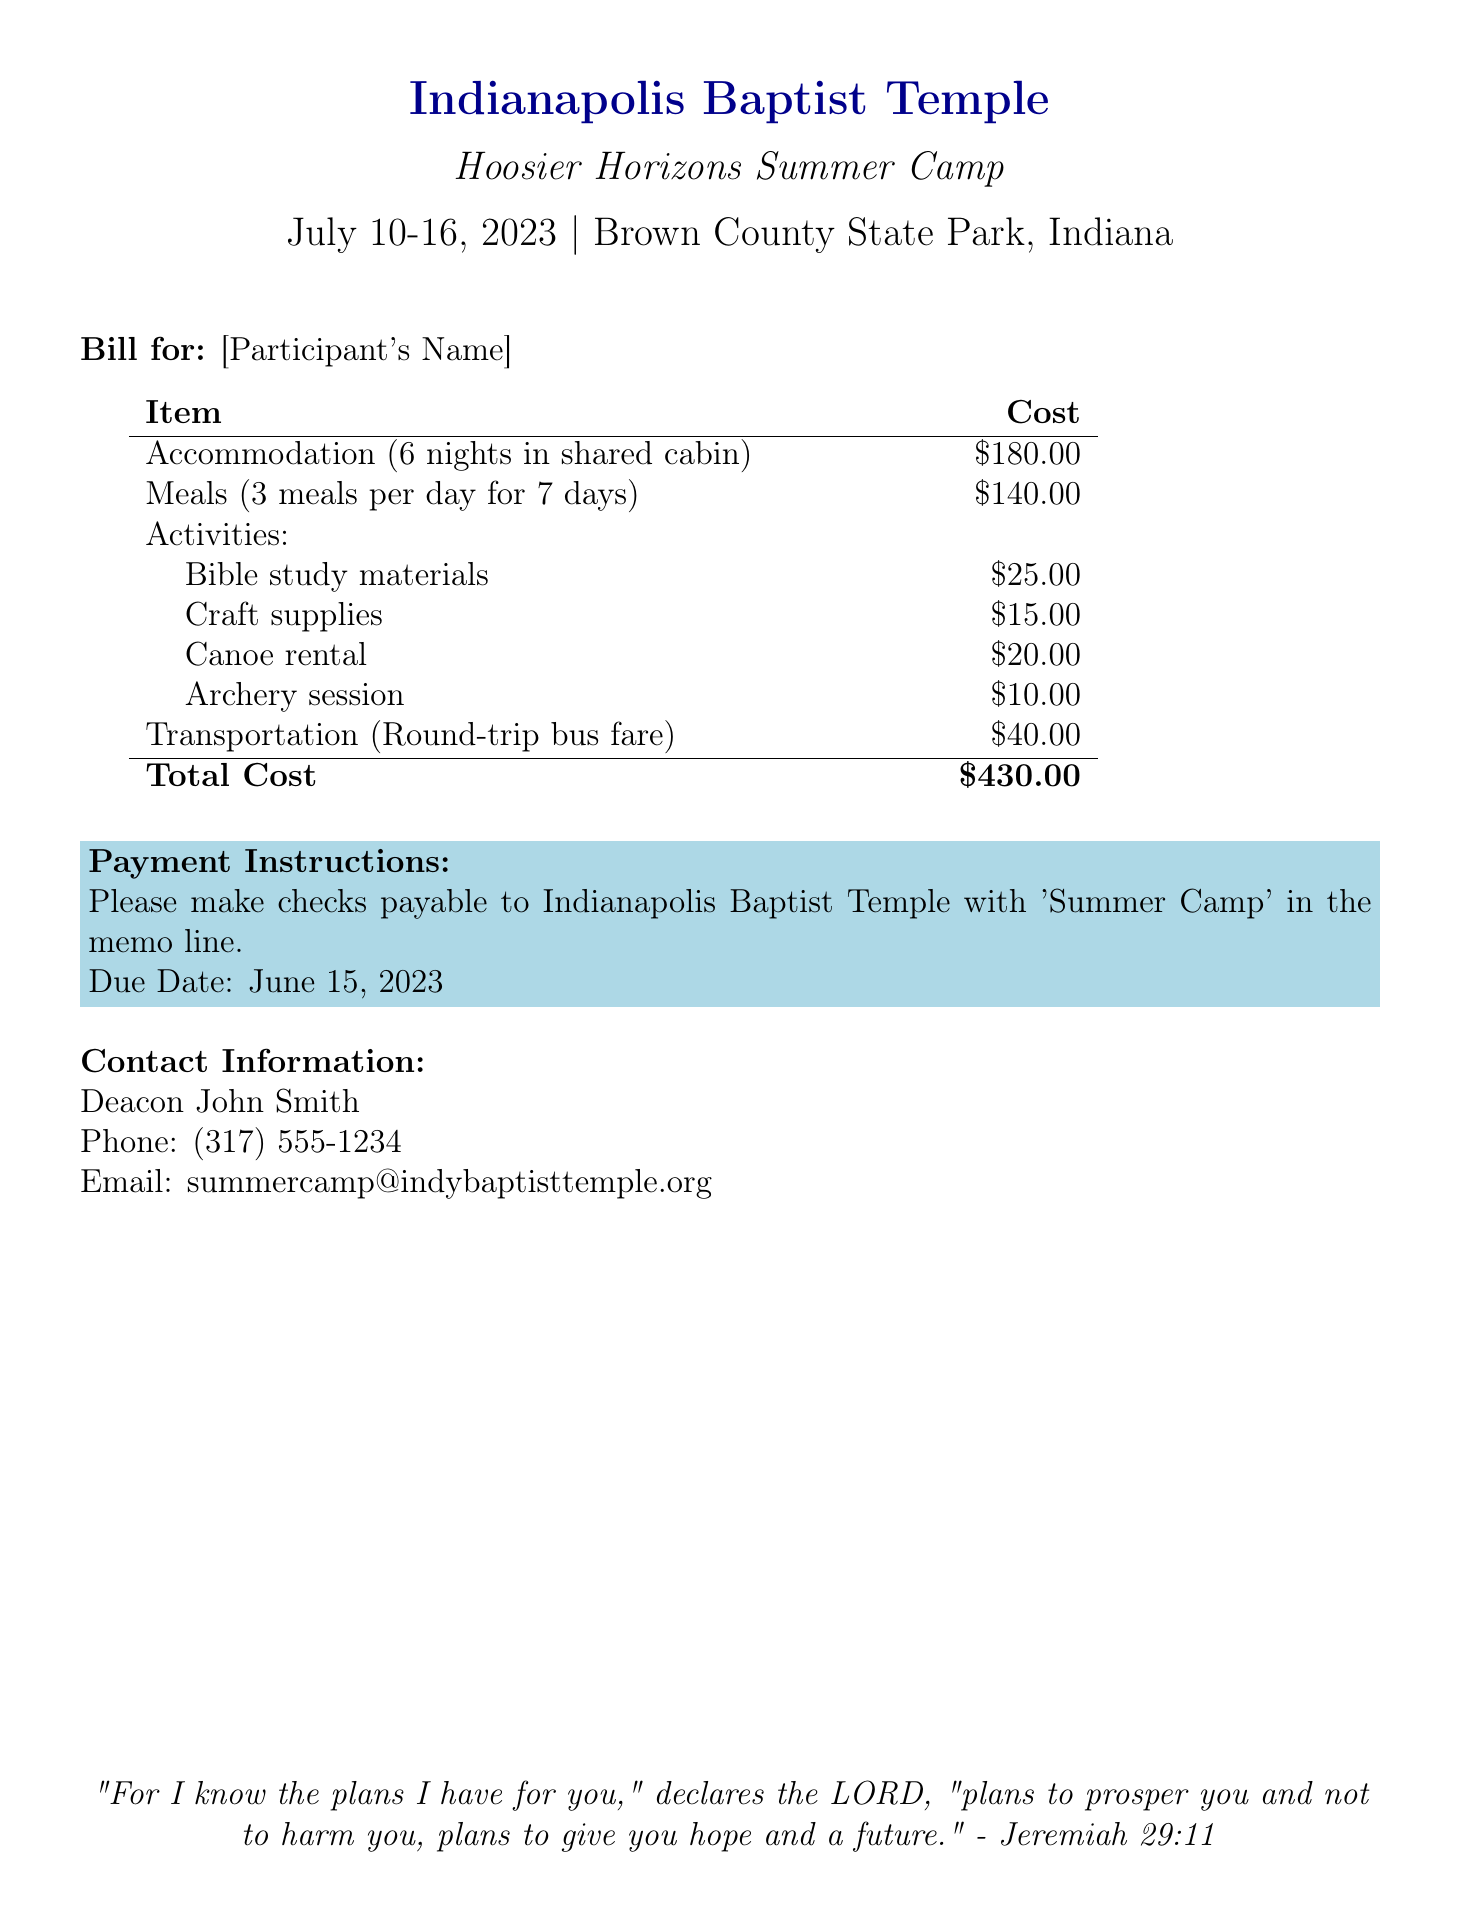What is the total cost? The total cost is the final amount listed in the bill, summarizing all expenses.
Answer: $430.00 What are the dates of the summer camp? The dates of the summer camp are clearly stated at the top of the document.
Answer: July 10-16, 2023 What type of activity is canoe rental? The canoe rental is listed as one of the activities that participants engage in during the camp.
Answer: Activity How much is the transportation cost? The cost for transportation is specified in the bill as part of the itemized list.
Answer: $40.00 What is the due date for payment? The due date for payment is mentioned in the payment instructions section of the document.
Answer: June 15, 2023 Who should checks be payable to? The document specifies who the checks should be made payable to for clarity on payment.
Answer: Indianapolis Baptist Temple How many meals are included per day? The document itemizes the meals included per day for the participants.
Answer: 3 meals What is the accommodation type? The accommodation type is specified in the bill as part of the accommodation details.
Answer: Shared cabin 